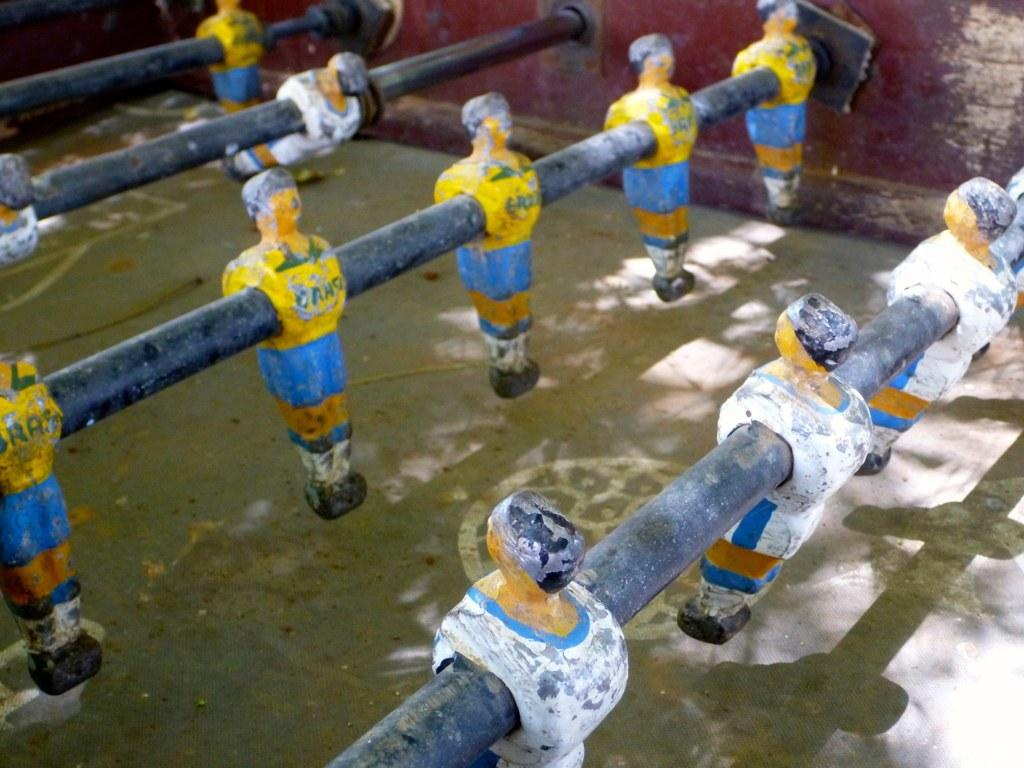What type of table is shown in the image? There is a foosball table in the image. What might people be doing around the foosball table? People might be playing foosball or standing nearby. Can you describe the design of the foosball table? The foosball table has rods with small figures attached, and there are goals at each end. What type of nerve is visible in the image? There is no nerve visible in the image; it features a foosball table. What type of weather can be seen in the image? The image does not show any weather conditions; it is focused on the foosball table. 